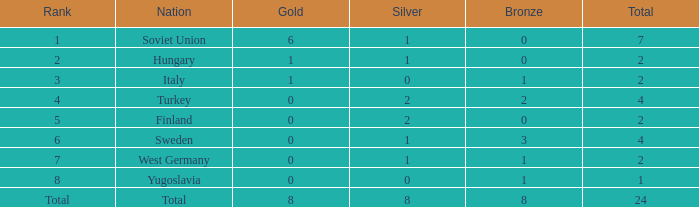What is the maximum total when gold equals 1, nation is hungary, and bronze is a negative value? None. Could you parse the entire table? {'header': ['Rank', 'Nation', 'Gold', 'Silver', 'Bronze', 'Total'], 'rows': [['1', 'Soviet Union', '6', '1', '0', '7'], ['2', 'Hungary', '1', '1', '0', '2'], ['3', 'Italy', '1', '0', '1', '2'], ['4', 'Turkey', '0', '2', '2', '4'], ['5', 'Finland', '0', '2', '0', '2'], ['6', 'Sweden', '0', '1', '3', '4'], ['7', 'West Germany', '0', '1', '1', '2'], ['8', 'Yugoslavia', '0', '0', '1', '1'], ['Total', 'Total', '8', '8', '8', '24']]} 